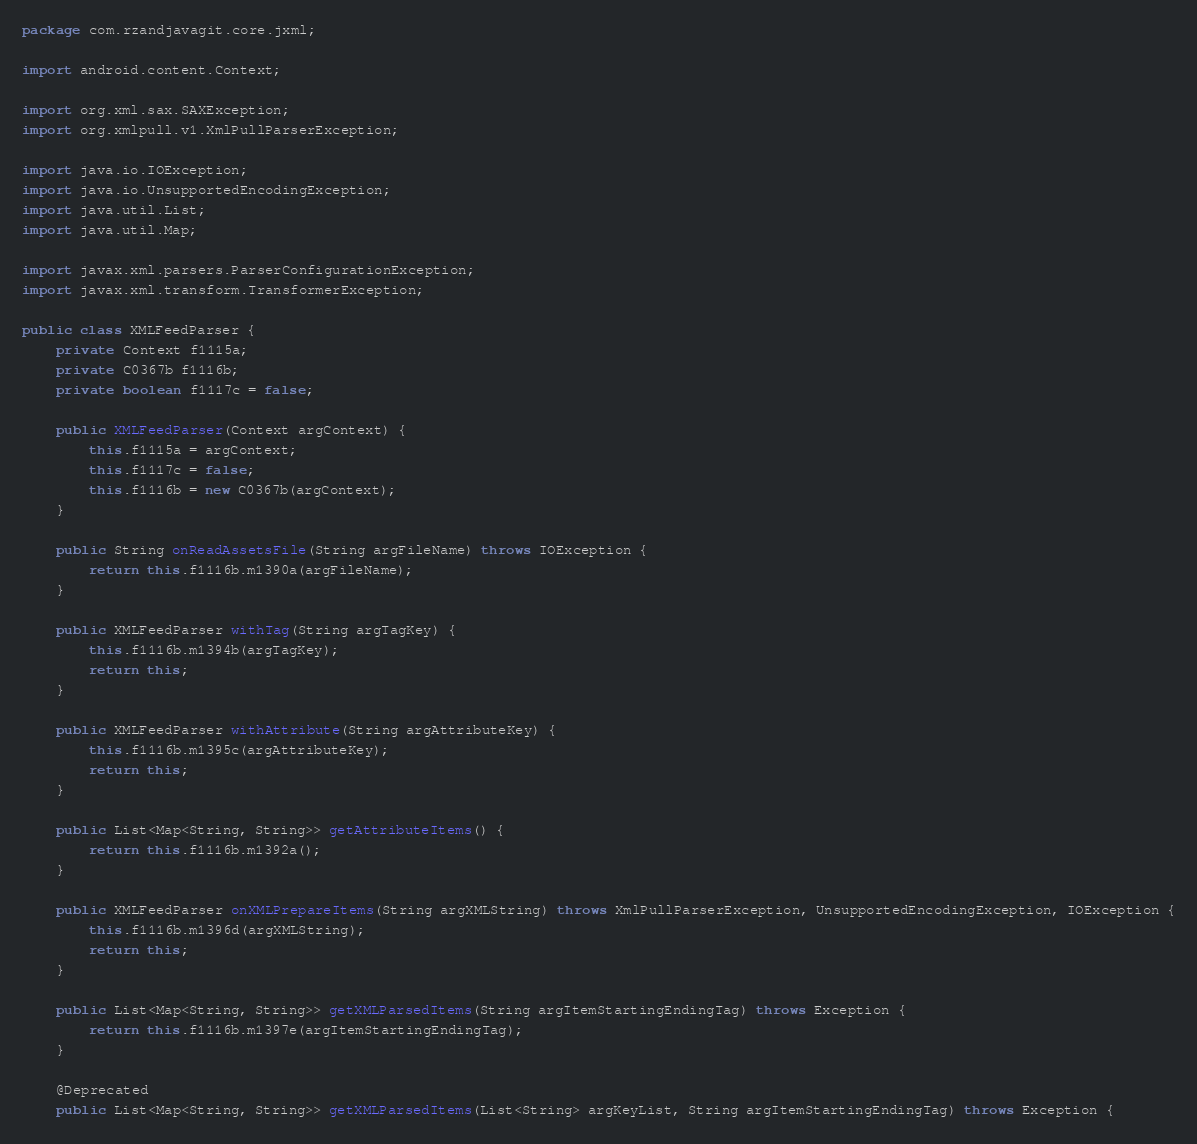Convert code to text. <code><loc_0><loc_0><loc_500><loc_500><_Java_>package com.rzandjavagit.core.jxml;

import android.content.Context;

import org.xml.sax.SAXException;
import org.xmlpull.v1.XmlPullParserException;

import java.io.IOException;
import java.io.UnsupportedEncodingException;
import java.util.List;
import java.util.Map;

import javax.xml.parsers.ParserConfigurationException;
import javax.xml.transform.TransformerException;

public class XMLFeedParser {
    private Context f1115a;
    private C0367b f1116b;
    private boolean f1117c = false;

    public XMLFeedParser(Context argContext) {
        this.f1115a = argContext;
        this.f1117c = false;
        this.f1116b = new C0367b(argContext);
    }

    public String onReadAssetsFile(String argFileName) throws IOException {
        return this.f1116b.m1390a(argFileName);
    }

    public XMLFeedParser withTag(String argTagKey) {
        this.f1116b.m1394b(argTagKey);
        return this;
    }

    public XMLFeedParser withAttribute(String argAttributeKey) {
        this.f1116b.m1395c(argAttributeKey);
        return this;
    }

    public List<Map<String, String>> getAttributeItems() {
        return this.f1116b.m1392a();
    }

    public XMLFeedParser onXMLPrepareItems(String argXMLString) throws XmlPullParserException, UnsupportedEncodingException, IOException {
        this.f1116b.m1396d(argXMLString);
        return this;
    }

    public List<Map<String, String>> getXMLParsedItems(String argItemStartingEndingTag) throws Exception {
        return this.f1116b.m1397e(argItemStartingEndingTag);
    }

    @Deprecated
    public List<Map<String, String>> getXMLParsedItems(List<String> argKeyList, String argItemStartingEndingTag) throws Exception {</code> 